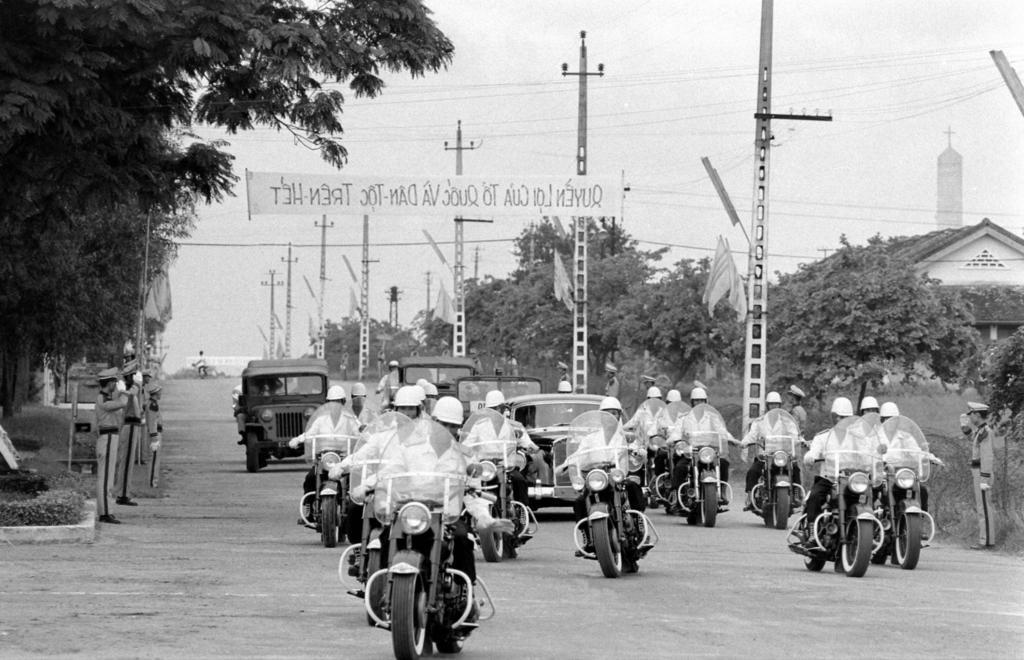Can you describe this image briefly? A black and white picture. We can able to see number of trees. These are current poles with cables. This is a house with roof top. A motor bikes and jeeps on road. Persons are sitting on a motorbike. This 3 persons are standing. On top there is a banner. 